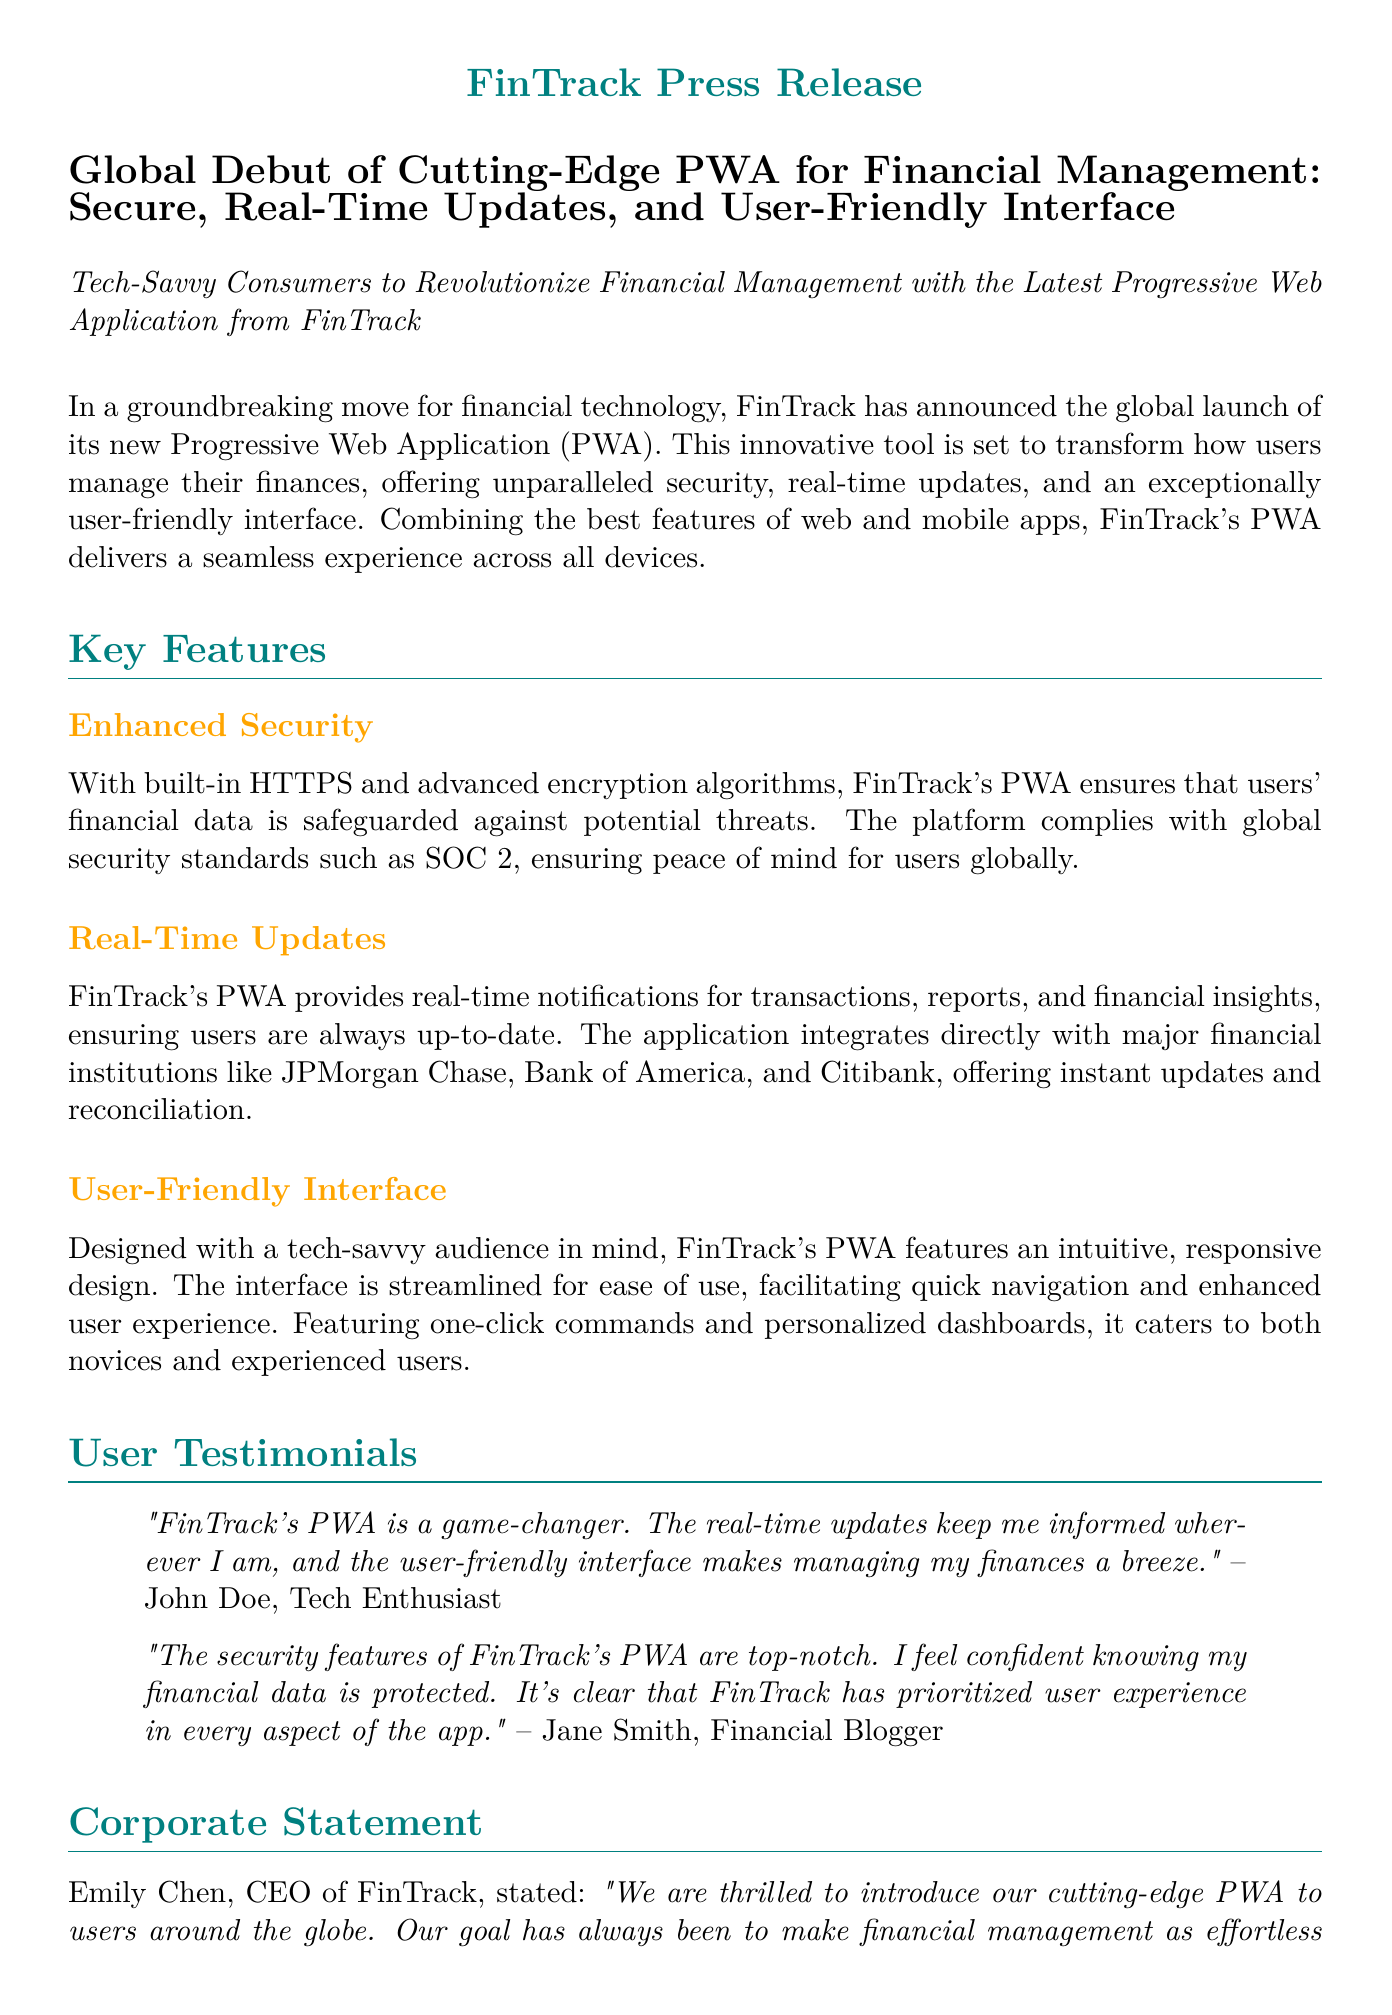What is the name of the PWA? The name of the PWA is mentioned in the press release as "FinTrack".
Answer: FinTrack What type of data protection does the PWA use? The press release states that the PWA uses "advanced encryption algorithms" for data protection.
Answer: Advanced encryption algorithms Who is the CEO of FinTrack? The CEO of FinTrack is named in the press release as Emily Chen.
Answer: Emily Chen Which financial institutions does the PWA integrate with? The document lists JPMorgan Chase, Bank of America, and Citibank as the financial institutions integrated with the PWA.
Answer: JPMorgan Chase, Bank of America, Citibank What is a key benefit of the user interface mentioned? The press release highlights that the user interface is designed for "ease of use".
Answer: Ease of use What does the PWA ensure according to the corporate statement? The corporate statement indicates that FinTrack's goal is to make financial management "as effortless as possible".
Answer: As effortless as possible What are users provided with in real-time? The document mentions that users are provided with "real-time notifications" for various financial activities.
Answer: Real-time notifications Where can the FinTrack PWA be downloaded? The press release provides the website where the PWA can be downloaded as www.fintrack.com.
Answer: www.fintrack.com 